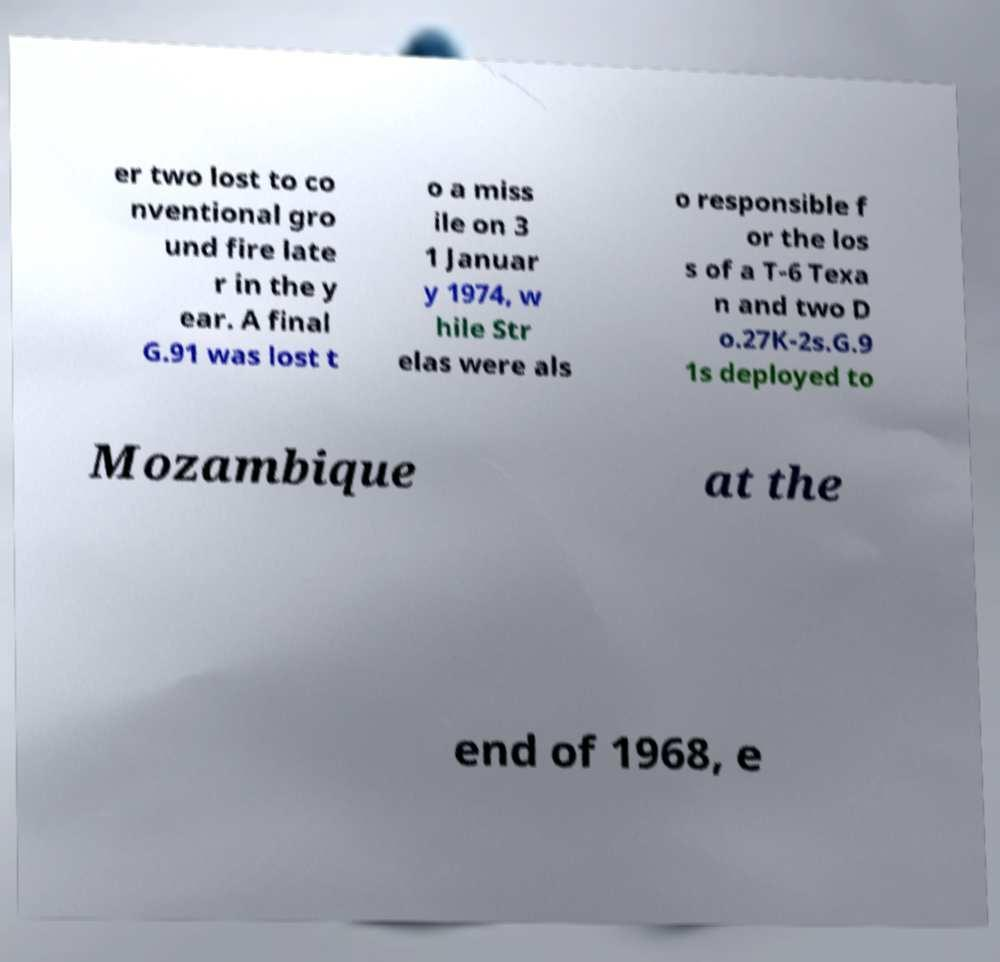Please read and relay the text visible in this image. What does it say? er two lost to co nventional gro und fire late r in the y ear. A final G.91 was lost t o a miss ile on 3 1 Januar y 1974, w hile Str elas were als o responsible f or the los s of a T-6 Texa n and two D o.27K-2s.G.9 1s deployed to Mozambique at the end of 1968, e 